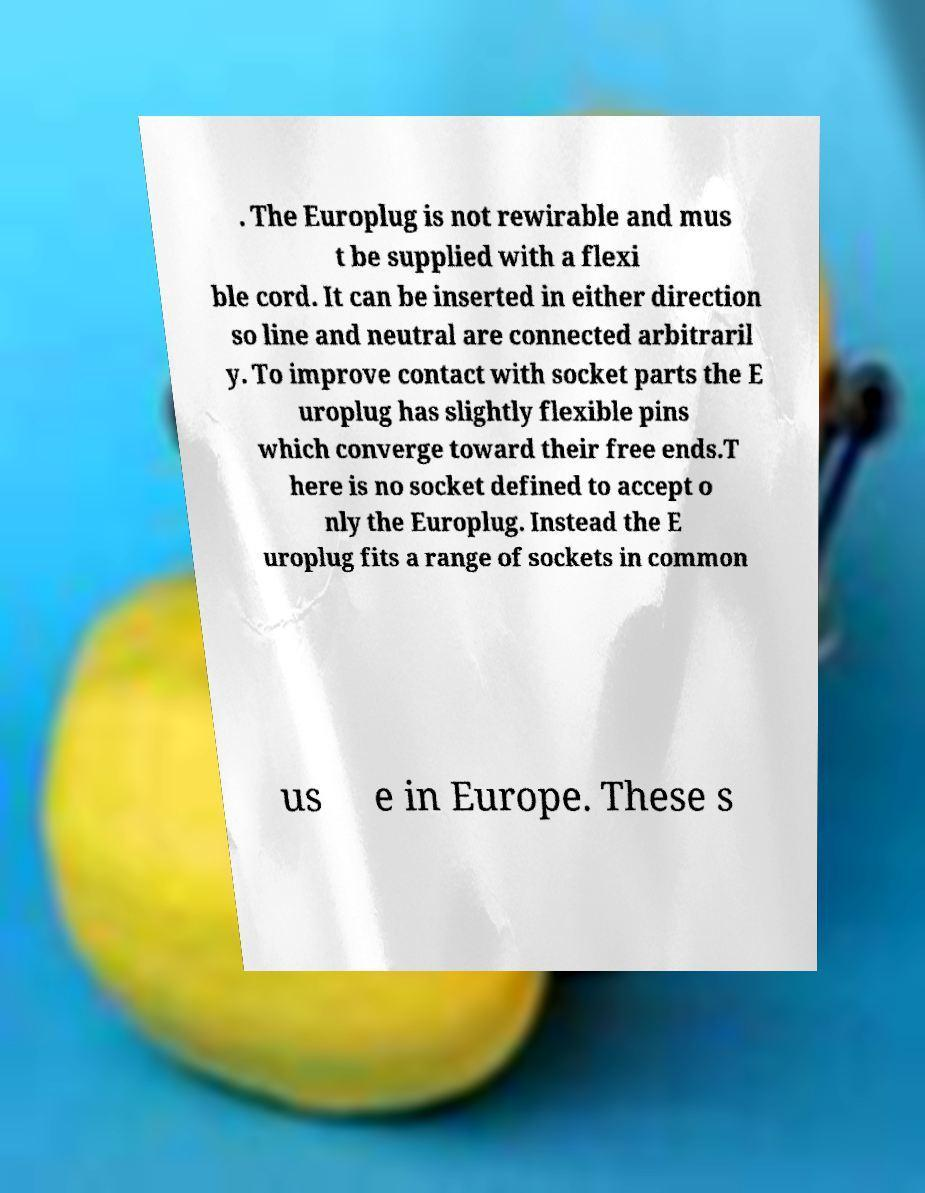Please identify and transcribe the text found in this image. . The Europlug is not rewirable and mus t be supplied with a flexi ble cord. It can be inserted in either direction so line and neutral are connected arbitraril y. To improve contact with socket parts the E uroplug has slightly flexible pins which converge toward their free ends.T here is no socket defined to accept o nly the Europlug. Instead the E uroplug fits a range of sockets in common us e in Europe. These s 